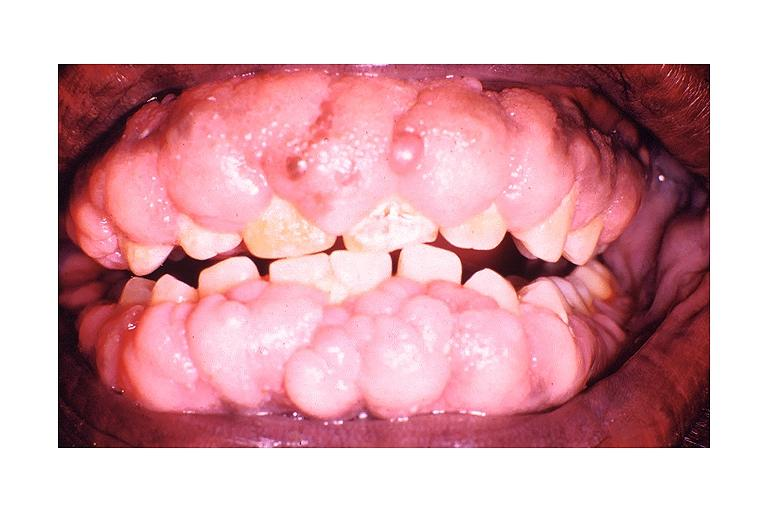what induced gingival hyperplasia?
Answer the question using a single word or phrase. Dilantin 